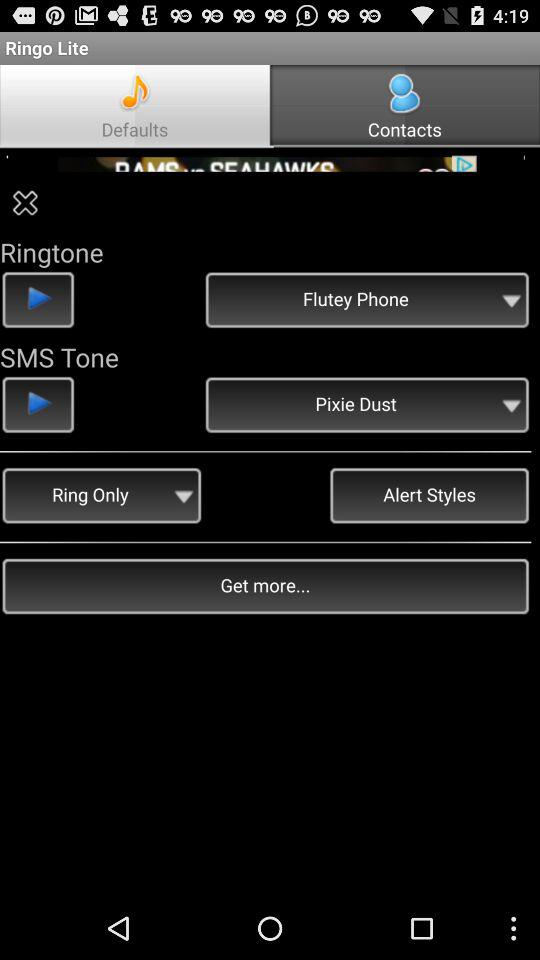What is the selected ring tone? The selected ring tone is flutey phone. 